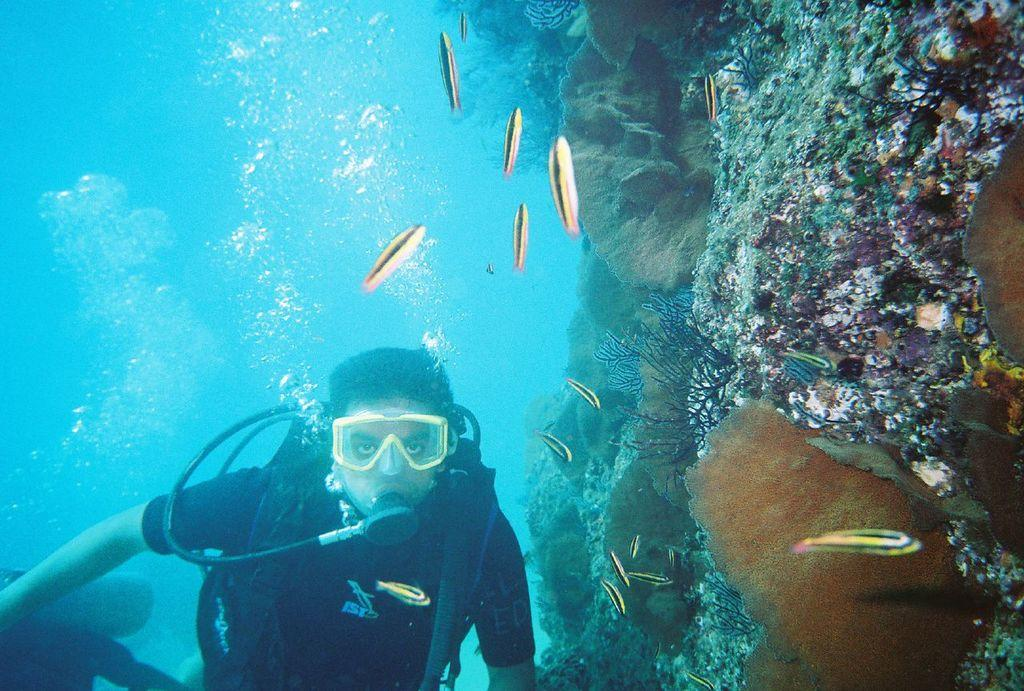Who or what is present in the image? There is a person in the image. What type of animals can be seen in the water? There are aquatic animals in the water. What other elements are visible in the image besides the person and animals? Plants and rocks are visible in the image. What type of doll is being sorted by the person in the image? There is no doll present in the image, and the person is not sorting anything. 